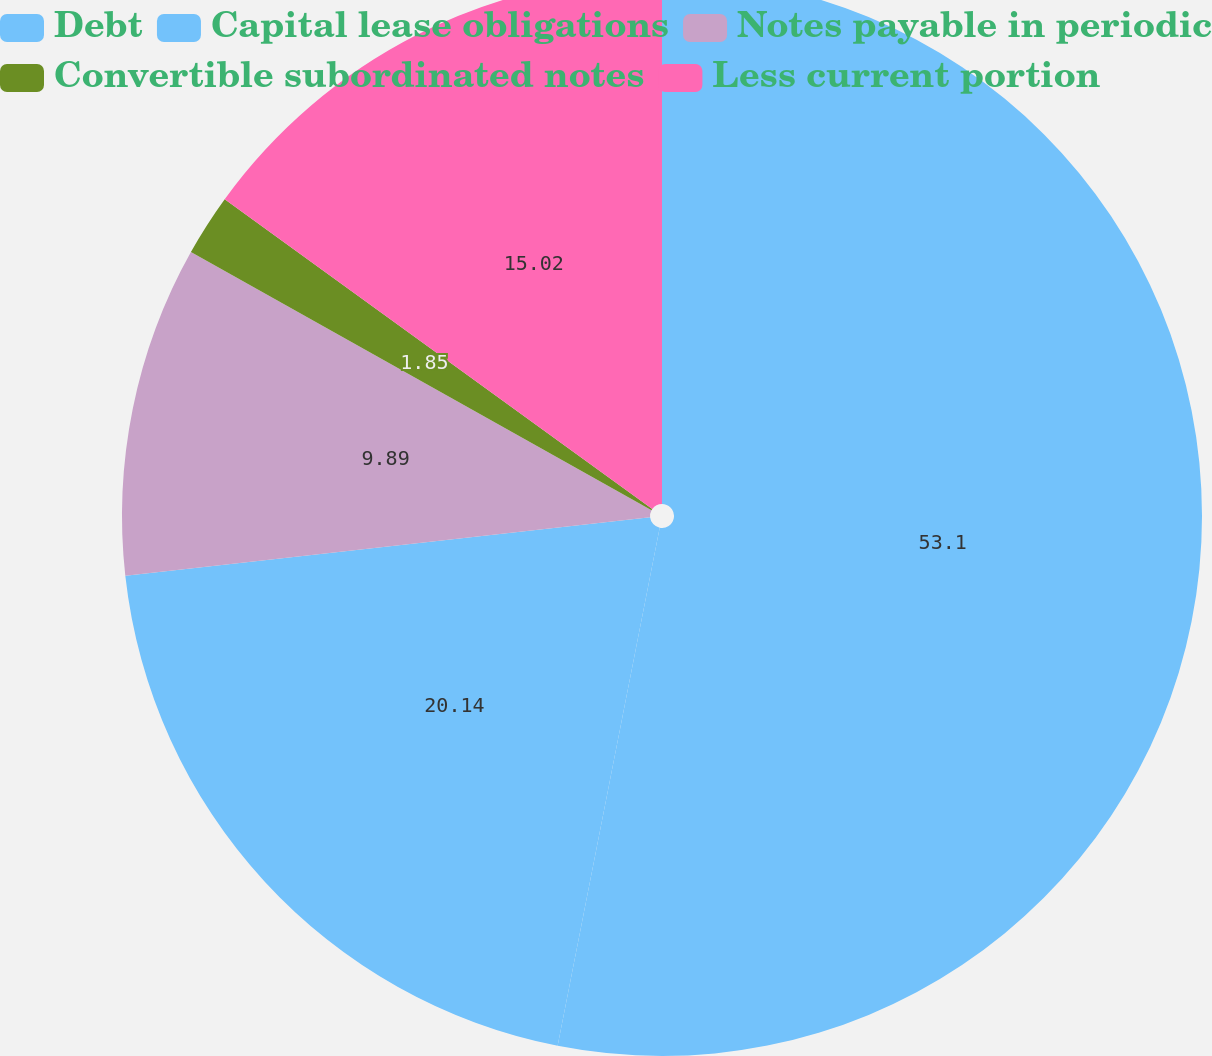Convert chart. <chart><loc_0><loc_0><loc_500><loc_500><pie_chart><fcel>Debt<fcel>Capital lease obligations<fcel>Notes payable in periodic<fcel>Convertible subordinated notes<fcel>Less current portion<nl><fcel>53.09%<fcel>20.14%<fcel>9.89%<fcel>1.85%<fcel>15.02%<nl></chart> 